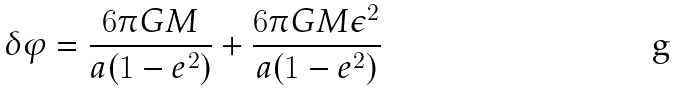Convert formula to latex. <formula><loc_0><loc_0><loc_500><loc_500>\delta \varphi = \frac { 6 \pi G M } { a ( 1 - e ^ { 2 } ) } + \frac { 6 \pi G M \epsilon ^ { 2 } } { a ( 1 - e ^ { 2 } ) }</formula> 